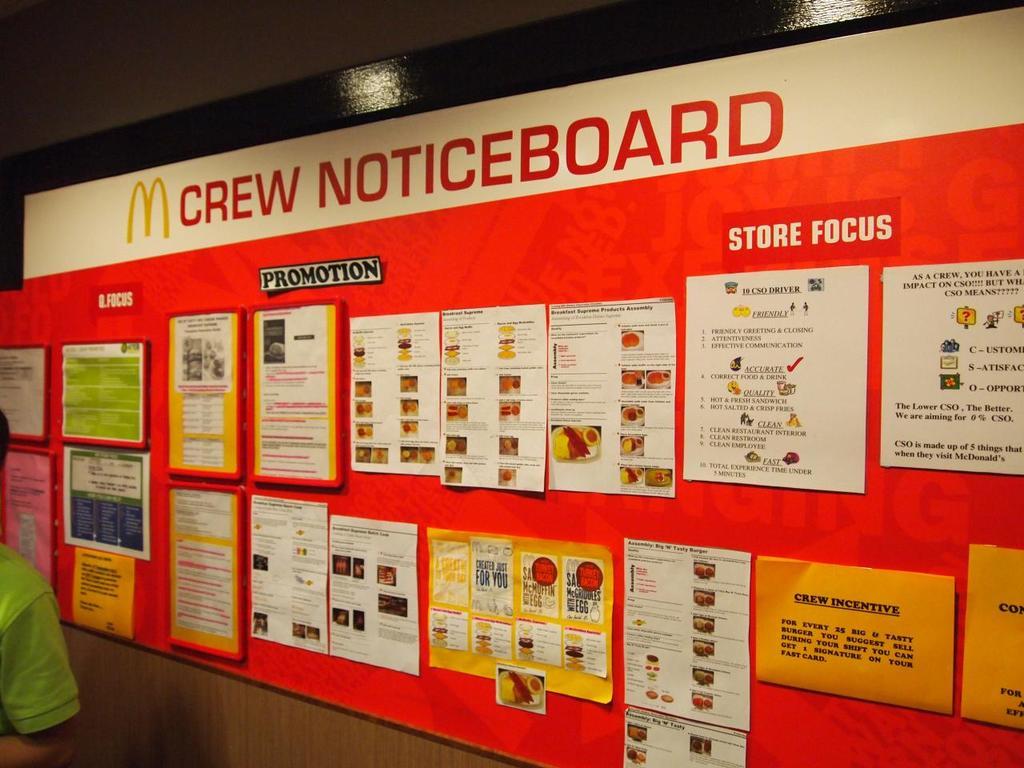What fastfood is this from?
Provide a short and direct response. Mcdonalds. What kind of board is this?
Your response must be concise. Crew noticeboard. 